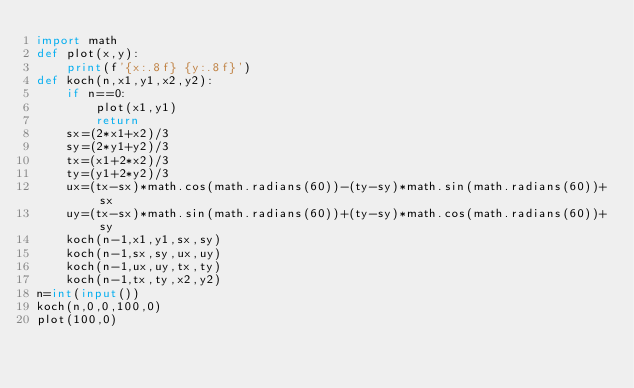<code> <loc_0><loc_0><loc_500><loc_500><_Python_>import math
def plot(x,y):
    print(f'{x:.8f} {y:.8f}')
def koch(n,x1,y1,x2,y2):
    if n==0:
        plot(x1,y1)
        return
    sx=(2*x1+x2)/3
    sy=(2*y1+y2)/3
    tx=(x1+2*x2)/3
    ty=(y1+2*y2)/3
    ux=(tx-sx)*math.cos(math.radians(60))-(ty-sy)*math.sin(math.radians(60))+sx
    uy=(tx-sx)*math.sin(math.radians(60))+(ty-sy)*math.cos(math.radians(60))+sy
    koch(n-1,x1,y1,sx,sy)
    koch(n-1,sx,sy,ux,uy)
    koch(n-1,ux,uy,tx,ty)
    koch(n-1,tx,ty,x2,y2)
n=int(input())
koch(n,0,0,100,0)
plot(100,0)
</code> 